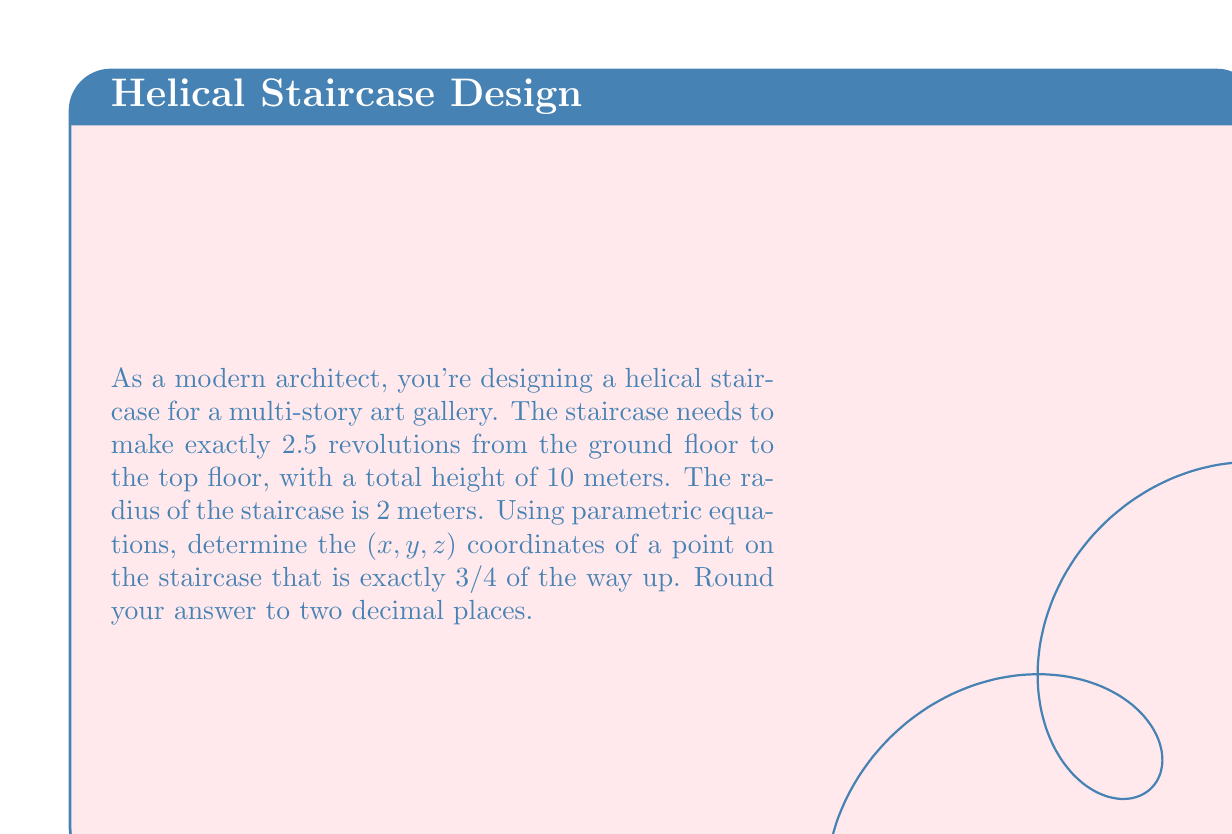Can you solve this math problem? Let's approach this step-by-step:

1) First, we need to set up the parametric equations for a helix. The general form is:

   $$x = r \cos(2\pi t)$$
   $$y = r \sin(2\pi t)$$
   $$z = ht$$

   Where $r$ is the radius, $h$ is the height of one complete revolution, and $t$ is the parameter (0 ≤ t ≤ number of revolutions).

2) We know:
   - Radius $r = 2$ meters
   - Total height = 10 meters
   - Number of revolutions = 2.5

3) To find $h$, we divide the total height by the number of revolutions:
   $$h = \frac{10}{2.5} = 4$$ meters per revolution

4) Our parametric equations become:
   $$x = 2 \cos(2\pi t)$$
   $$y = 2 \sin(2\pi t)$$
   $$z = 4t$$

5) We need to find the point 3/4 of the way up. This means:
   $$t = 2.5 * \frac{3}{4} = 1.875$$

6) Now we can calculate our coordinates:
   $$x = 2 \cos(2\pi * 1.875) = 2 \cos(3.75\pi) \approx 0$$
   $$y = 2 \sin(2\pi * 1.875) = 2 \sin(3.75\pi) \approx -2$$
   $$z = 4 * 1.875 = 7.5$$

7) Rounding to two decimal places:
   $x \approx 0.00$
   $y \approx -2.00$
   $z = 7.50$
Answer: (0.00, -2.00, 7.50) 